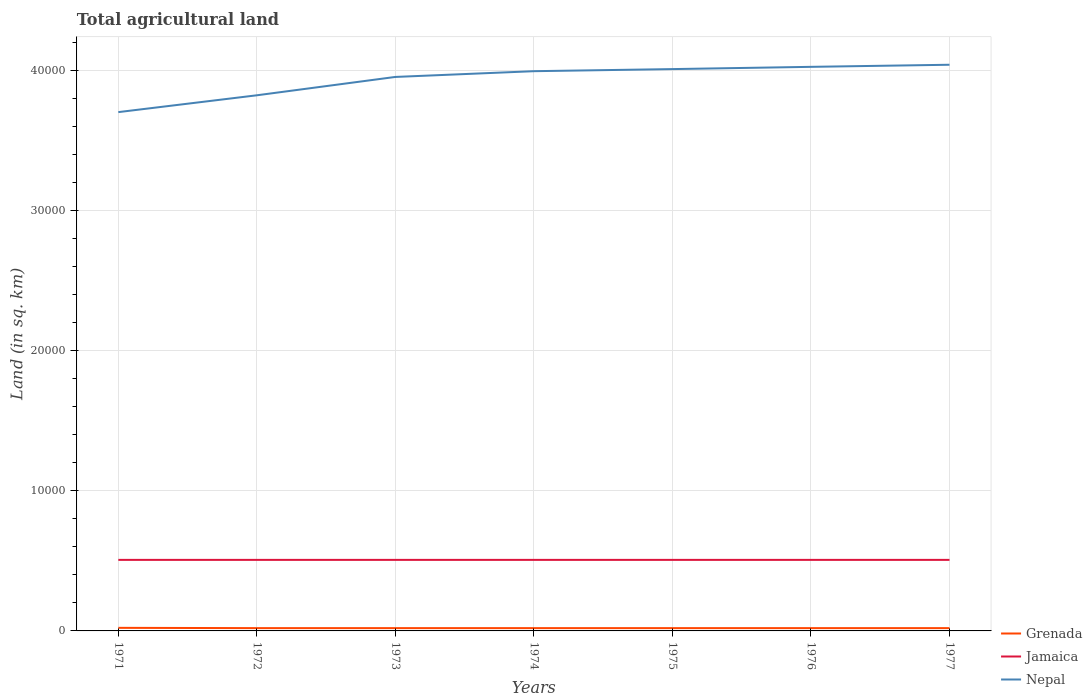Does the line corresponding to Nepal intersect with the line corresponding to Jamaica?
Offer a terse response. No. Across all years, what is the maximum total agricultural land in Grenada?
Your answer should be very brief. 200. What is the total total agricultural land in Grenada in the graph?
Ensure brevity in your answer.  20. What is the difference between the highest and the second highest total agricultural land in Nepal?
Ensure brevity in your answer.  3380. Is the total agricultural land in Grenada strictly greater than the total agricultural land in Jamaica over the years?
Ensure brevity in your answer.  Yes. How many lines are there?
Give a very brief answer. 3. How many years are there in the graph?
Offer a very short reply. 7. Are the values on the major ticks of Y-axis written in scientific E-notation?
Your answer should be very brief. No. Does the graph contain any zero values?
Provide a short and direct response. No. How many legend labels are there?
Provide a short and direct response. 3. How are the legend labels stacked?
Your response must be concise. Vertical. What is the title of the graph?
Keep it short and to the point. Total agricultural land. Does "Panama" appear as one of the legend labels in the graph?
Offer a terse response. No. What is the label or title of the X-axis?
Your answer should be compact. Years. What is the label or title of the Y-axis?
Give a very brief answer. Land (in sq. km). What is the Land (in sq. km) of Grenada in 1971?
Offer a very short reply. 220. What is the Land (in sq. km) of Jamaica in 1971?
Ensure brevity in your answer.  5070. What is the Land (in sq. km) in Nepal in 1971?
Provide a short and direct response. 3.70e+04. What is the Land (in sq. km) in Grenada in 1972?
Give a very brief answer. 200. What is the Land (in sq. km) of Jamaica in 1972?
Give a very brief answer. 5070. What is the Land (in sq. km) of Nepal in 1972?
Give a very brief answer. 3.82e+04. What is the Land (in sq. km) in Jamaica in 1973?
Provide a short and direct response. 5070. What is the Land (in sq. km) in Nepal in 1973?
Offer a very short reply. 3.95e+04. What is the Land (in sq. km) in Jamaica in 1974?
Provide a succinct answer. 5070. What is the Land (in sq. km) of Nepal in 1974?
Your answer should be compact. 3.99e+04. What is the Land (in sq. km) in Grenada in 1975?
Provide a short and direct response. 200. What is the Land (in sq. km) in Jamaica in 1975?
Give a very brief answer. 5070. What is the Land (in sq. km) of Nepal in 1975?
Provide a short and direct response. 4.01e+04. What is the Land (in sq. km) in Grenada in 1976?
Keep it short and to the point. 200. What is the Land (in sq. km) of Jamaica in 1976?
Offer a terse response. 5070. What is the Land (in sq. km) of Nepal in 1976?
Your answer should be compact. 4.02e+04. What is the Land (in sq. km) of Grenada in 1977?
Your answer should be compact. 200. What is the Land (in sq. km) of Jamaica in 1977?
Ensure brevity in your answer.  5070. What is the Land (in sq. km) in Nepal in 1977?
Offer a terse response. 4.04e+04. Across all years, what is the maximum Land (in sq. km) in Grenada?
Your response must be concise. 220. Across all years, what is the maximum Land (in sq. km) of Jamaica?
Provide a succinct answer. 5070. Across all years, what is the maximum Land (in sq. km) of Nepal?
Make the answer very short. 4.04e+04. Across all years, what is the minimum Land (in sq. km) in Grenada?
Ensure brevity in your answer.  200. Across all years, what is the minimum Land (in sq. km) of Jamaica?
Give a very brief answer. 5070. Across all years, what is the minimum Land (in sq. km) in Nepal?
Ensure brevity in your answer.  3.70e+04. What is the total Land (in sq. km) in Grenada in the graph?
Your response must be concise. 1420. What is the total Land (in sq. km) in Jamaica in the graph?
Provide a succinct answer. 3.55e+04. What is the total Land (in sq. km) of Nepal in the graph?
Provide a short and direct response. 2.75e+05. What is the difference between the Land (in sq. km) of Grenada in 1971 and that in 1972?
Ensure brevity in your answer.  20. What is the difference between the Land (in sq. km) of Jamaica in 1971 and that in 1972?
Your answer should be very brief. 0. What is the difference between the Land (in sq. km) in Nepal in 1971 and that in 1972?
Provide a short and direct response. -1200. What is the difference between the Land (in sq. km) of Grenada in 1971 and that in 1973?
Offer a terse response. 20. What is the difference between the Land (in sq. km) of Jamaica in 1971 and that in 1973?
Your response must be concise. 0. What is the difference between the Land (in sq. km) of Nepal in 1971 and that in 1973?
Keep it short and to the point. -2510. What is the difference between the Land (in sq. km) in Nepal in 1971 and that in 1974?
Keep it short and to the point. -2920. What is the difference between the Land (in sq. km) in Jamaica in 1971 and that in 1975?
Your response must be concise. 0. What is the difference between the Land (in sq. km) in Nepal in 1971 and that in 1975?
Your answer should be compact. -3070. What is the difference between the Land (in sq. km) of Grenada in 1971 and that in 1976?
Your response must be concise. 20. What is the difference between the Land (in sq. km) in Jamaica in 1971 and that in 1976?
Ensure brevity in your answer.  0. What is the difference between the Land (in sq. km) of Nepal in 1971 and that in 1976?
Provide a short and direct response. -3230. What is the difference between the Land (in sq. km) of Nepal in 1971 and that in 1977?
Provide a short and direct response. -3380. What is the difference between the Land (in sq. km) of Grenada in 1972 and that in 1973?
Your answer should be very brief. 0. What is the difference between the Land (in sq. km) of Nepal in 1972 and that in 1973?
Your response must be concise. -1310. What is the difference between the Land (in sq. km) in Grenada in 1972 and that in 1974?
Provide a short and direct response. 0. What is the difference between the Land (in sq. km) of Jamaica in 1972 and that in 1974?
Offer a very short reply. 0. What is the difference between the Land (in sq. km) of Nepal in 1972 and that in 1974?
Ensure brevity in your answer.  -1720. What is the difference between the Land (in sq. km) of Nepal in 1972 and that in 1975?
Provide a short and direct response. -1870. What is the difference between the Land (in sq. km) in Grenada in 1972 and that in 1976?
Offer a very short reply. 0. What is the difference between the Land (in sq. km) in Jamaica in 1972 and that in 1976?
Your response must be concise. 0. What is the difference between the Land (in sq. km) in Nepal in 1972 and that in 1976?
Your answer should be very brief. -2030. What is the difference between the Land (in sq. km) of Jamaica in 1972 and that in 1977?
Ensure brevity in your answer.  0. What is the difference between the Land (in sq. km) in Nepal in 1972 and that in 1977?
Offer a very short reply. -2180. What is the difference between the Land (in sq. km) of Grenada in 1973 and that in 1974?
Ensure brevity in your answer.  0. What is the difference between the Land (in sq. km) of Jamaica in 1973 and that in 1974?
Make the answer very short. 0. What is the difference between the Land (in sq. km) in Nepal in 1973 and that in 1974?
Ensure brevity in your answer.  -410. What is the difference between the Land (in sq. km) in Nepal in 1973 and that in 1975?
Ensure brevity in your answer.  -560. What is the difference between the Land (in sq. km) of Grenada in 1973 and that in 1976?
Your answer should be very brief. 0. What is the difference between the Land (in sq. km) in Jamaica in 1973 and that in 1976?
Make the answer very short. 0. What is the difference between the Land (in sq. km) of Nepal in 1973 and that in 1976?
Your answer should be compact. -720. What is the difference between the Land (in sq. km) of Grenada in 1973 and that in 1977?
Provide a short and direct response. 0. What is the difference between the Land (in sq. km) in Jamaica in 1973 and that in 1977?
Your answer should be very brief. 0. What is the difference between the Land (in sq. km) of Nepal in 1973 and that in 1977?
Offer a terse response. -870. What is the difference between the Land (in sq. km) in Grenada in 1974 and that in 1975?
Provide a short and direct response. 0. What is the difference between the Land (in sq. km) of Jamaica in 1974 and that in 1975?
Keep it short and to the point. 0. What is the difference between the Land (in sq. km) of Nepal in 1974 and that in 1975?
Provide a short and direct response. -150. What is the difference between the Land (in sq. km) of Nepal in 1974 and that in 1976?
Give a very brief answer. -310. What is the difference between the Land (in sq. km) in Nepal in 1974 and that in 1977?
Provide a short and direct response. -460. What is the difference between the Land (in sq. km) in Grenada in 1975 and that in 1976?
Ensure brevity in your answer.  0. What is the difference between the Land (in sq. km) of Nepal in 1975 and that in 1976?
Ensure brevity in your answer.  -160. What is the difference between the Land (in sq. km) in Jamaica in 1975 and that in 1977?
Give a very brief answer. 0. What is the difference between the Land (in sq. km) in Nepal in 1975 and that in 1977?
Offer a very short reply. -310. What is the difference between the Land (in sq. km) of Jamaica in 1976 and that in 1977?
Your response must be concise. 0. What is the difference between the Land (in sq. km) in Nepal in 1976 and that in 1977?
Offer a terse response. -150. What is the difference between the Land (in sq. km) in Grenada in 1971 and the Land (in sq. km) in Jamaica in 1972?
Give a very brief answer. -4850. What is the difference between the Land (in sq. km) of Grenada in 1971 and the Land (in sq. km) of Nepal in 1972?
Make the answer very short. -3.80e+04. What is the difference between the Land (in sq. km) of Jamaica in 1971 and the Land (in sq. km) of Nepal in 1972?
Provide a short and direct response. -3.32e+04. What is the difference between the Land (in sq. km) of Grenada in 1971 and the Land (in sq. km) of Jamaica in 1973?
Provide a succinct answer. -4850. What is the difference between the Land (in sq. km) of Grenada in 1971 and the Land (in sq. km) of Nepal in 1973?
Offer a very short reply. -3.93e+04. What is the difference between the Land (in sq. km) of Jamaica in 1971 and the Land (in sq. km) of Nepal in 1973?
Your answer should be very brief. -3.45e+04. What is the difference between the Land (in sq. km) in Grenada in 1971 and the Land (in sq. km) in Jamaica in 1974?
Provide a short and direct response. -4850. What is the difference between the Land (in sq. km) in Grenada in 1971 and the Land (in sq. km) in Nepal in 1974?
Keep it short and to the point. -3.97e+04. What is the difference between the Land (in sq. km) in Jamaica in 1971 and the Land (in sq. km) in Nepal in 1974?
Your answer should be compact. -3.49e+04. What is the difference between the Land (in sq. km) of Grenada in 1971 and the Land (in sq. km) of Jamaica in 1975?
Offer a very short reply. -4850. What is the difference between the Land (in sq. km) of Grenada in 1971 and the Land (in sq. km) of Nepal in 1975?
Offer a very short reply. -3.99e+04. What is the difference between the Land (in sq. km) of Jamaica in 1971 and the Land (in sq. km) of Nepal in 1975?
Provide a succinct answer. -3.50e+04. What is the difference between the Land (in sq. km) in Grenada in 1971 and the Land (in sq. km) in Jamaica in 1976?
Your response must be concise. -4850. What is the difference between the Land (in sq. km) of Grenada in 1971 and the Land (in sq. km) of Nepal in 1976?
Keep it short and to the point. -4.00e+04. What is the difference between the Land (in sq. km) in Jamaica in 1971 and the Land (in sq. km) in Nepal in 1976?
Offer a very short reply. -3.52e+04. What is the difference between the Land (in sq. km) in Grenada in 1971 and the Land (in sq. km) in Jamaica in 1977?
Ensure brevity in your answer.  -4850. What is the difference between the Land (in sq. km) in Grenada in 1971 and the Land (in sq. km) in Nepal in 1977?
Ensure brevity in your answer.  -4.02e+04. What is the difference between the Land (in sq. km) in Jamaica in 1971 and the Land (in sq. km) in Nepal in 1977?
Your answer should be compact. -3.53e+04. What is the difference between the Land (in sq. km) of Grenada in 1972 and the Land (in sq. km) of Jamaica in 1973?
Provide a succinct answer. -4870. What is the difference between the Land (in sq. km) in Grenada in 1972 and the Land (in sq. km) in Nepal in 1973?
Make the answer very short. -3.93e+04. What is the difference between the Land (in sq. km) of Jamaica in 1972 and the Land (in sq. km) of Nepal in 1973?
Your answer should be compact. -3.45e+04. What is the difference between the Land (in sq. km) in Grenada in 1972 and the Land (in sq. km) in Jamaica in 1974?
Ensure brevity in your answer.  -4870. What is the difference between the Land (in sq. km) in Grenada in 1972 and the Land (in sq. km) in Nepal in 1974?
Give a very brief answer. -3.97e+04. What is the difference between the Land (in sq. km) in Jamaica in 1972 and the Land (in sq. km) in Nepal in 1974?
Offer a very short reply. -3.49e+04. What is the difference between the Land (in sq. km) in Grenada in 1972 and the Land (in sq. km) in Jamaica in 1975?
Make the answer very short. -4870. What is the difference between the Land (in sq. km) in Grenada in 1972 and the Land (in sq. km) in Nepal in 1975?
Give a very brief answer. -3.99e+04. What is the difference between the Land (in sq. km) of Jamaica in 1972 and the Land (in sq. km) of Nepal in 1975?
Your answer should be very brief. -3.50e+04. What is the difference between the Land (in sq. km) of Grenada in 1972 and the Land (in sq. km) of Jamaica in 1976?
Your answer should be very brief. -4870. What is the difference between the Land (in sq. km) of Grenada in 1972 and the Land (in sq. km) of Nepal in 1976?
Provide a short and direct response. -4.00e+04. What is the difference between the Land (in sq. km) of Jamaica in 1972 and the Land (in sq. km) of Nepal in 1976?
Your answer should be compact. -3.52e+04. What is the difference between the Land (in sq. km) of Grenada in 1972 and the Land (in sq. km) of Jamaica in 1977?
Your answer should be compact. -4870. What is the difference between the Land (in sq. km) of Grenada in 1972 and the Land (in sq. km) of Nepal in 1977?
Provide a short and direct response. -4.02e+04. What is the difference between the Land (in sq. km) of Jamaica in 1972 and the Land (in sq. km) of Nepal in 1977?
Ensure brevity in your answer.  -3.53e+04. What is the difference between the Land (in sq. km) of Grenada in 1973 and the Land (in sq. km) of Jamaica in 1974?
Ensure brevity in your answer.  -4870. What is the difference between the Land (in sq. km) of Grenada in 1973 and the Land (in sq. km) of Nepal in 1974?
Provide a succinct answer. -3.97e+04. What is the difference between the Land (in sq. km) of Jamaica in 1973 and the Land (in sq. km) of Nepal in 1974?
Provide a short and direct response. -3.49e+04. What is the difference between the Land (in sq. km) in Grenada in 1973 and the Land (in sq. km) in Jamaica in 1975?
Offer a very short reply. -4870. What is the difference between the Land (in sq. km) of Grenada in 1973 and the Land (in sq. km) of Nepal in 1975?
Ensure brevity in your answer.  -3.99e+04. What is the difference between the Land (in sq. km) in Jamaica in 1973 and the Land (in sq. km) in Nepal in 1975?
Offer a terse response. -3.50e+04. What is the difference between the Land (in sq. km) of Grenada in 1973 and the Land (in sq. km) of Jamaica in 1976?
Ensure brevity in your answer.  -4870. What is the difference between the Land (in sq. km) in Grenada in 1973 and the Land (in sq. km) in Nepal in 1976?
Your response must be concise. -4.00e+04. What is the difference between the Land (in sq. km) of Jamaica in 1973 and the Land (in sq. km) of Nepal in 1976?
Make the answer very short. -3.52e+04. What is the difference between the Land (in sq. km) in Grenada in 1973 and the Land (in sq. km) in Jamaica in 1977?
Make the answer very short. -4870. What is the difference between the Land (in sq. km) of Grenada in 1973 and the Land (in sq. km) of Nepal in 1977?
Offer a terse response. -4.02e+04. What is the difference between the Land (in sq. km) of Jamaica in 1973 and the Land (in sq. km) of Nepal in 1977?
Provide a succinct answer. -3.53e+04. What is the difference between the Land (in sq. km) of Grenada in 1974 and the Land (in sq. km) of Jamaica in 1975?
Ensure brevity in your answer.  -4870. What is the difference between the Land (in sq. km) of Grenada in 1974 and the Land (in sq. km) of Nepal in 1975?
Your answer should be very brief. -3.99e+04. What is the difference between the Land (in sq. km) in Jamaica in 1974 and the Land (in sq. km) in Nepal in 1975?
Your answer should be very brief. -3.50e+04. What is the difference between the Land (in sq. km) of Grenada in 1974 and the Land (in sq. km) of Jamaica in 1976?
Your response must be concise. -4870. What is the difference between the Land (in sq. km) in Grenada in 1974 and the Land (in sq. km) in Nepal in 1976?
Provide a short and direct response. -4.00e+04. What is the difference between the Land (in sq. km) in Jamaica in 1974 and the Land (in sq. km) in Nepal in 1976?
Keep it short and to the point. -3.52e+04. What is the difference between the Land (in sq. km) in Grenada in 1974 and the Land (in sq. km) in Jamaica in 1977?
Your answer should be very brief. -4870. What is the difference between the Land (in sq. km) in Grenada in 1974 and the Land (in sq. km) in Nepal in 1977?
Make the answer very short. -4.02e+04. What is the difference between the Land (in sq. km) of Jamaica in 1974 and the Land (in sq. km) of Nepal in 1977?
Provide a short and direct response. -3.53e+04. What is the difference between the Land (in sq. km) of Grenada in 1975 and the Land (in sq. km) of Jamaica in 1976?
Your answer should be compact. -4870. What is the difference between the Land (in sq. km) of Grenada in 1975 and the Land (in sq. km) of Nepal in 1976?
Ensure brevity in your answer.  -4.00e+04. What is the difference between the Land (in sq. km) of Jamaica in 1975 and the Land (in sq. km) of Nepal in 1976?
Give a very brief answer. -3.52e+04. What is the difference between the Land (in sq. km) of Grenada in 1975 and the Land (in sq. km) of Jamaica in 1977?
Offer a terse response. -4870. What is the difference between the Land (in sq. km) in Grenada in 1975 and the Land (in sq. km) in Nepal in 1977?
Your answer should be compact. -4.02e+04. What is the difference between the Land (in sq. km) in Jamaica in 1975 and the Land (in sq. km) in Nepal in 1977?
Offer a very short reply. -3.53e+04. What is the difference between the Land (in sq. km) of Grenada in 1976 and the Land (in sq. km) of Jamaica in 1977?
Provide a short and direct response. -4870. What is the difference between the Land (in sq. km) in Grenada in 1976 and the Land (in sq. km) in Nepal in 1977?
Offer a very short reply. -4.02e+04. What is the difference between the Land (in sq. km) in Jamaica in 1976 and the Land (in sq. km) in Nepal in 1977?
Provide a succinct answer. -3.53e+04. What is the average Land (in sq. km) in Grenada per year?
Make the answer very short. 202.86. What is the average Land (in sq. km) of Jamaica per year?
Provide a succinct answer. 5070. What is the average Land (in sq. km) of Nepal per year?
Give a very brief answer. 3.94e+04. In the year 1971, what is the difference between the Land (in sq. km) in Grenada and Land (in sq. km) in Jamaica?
Offer a terse response. -4850. In the year 1971, what is the difference between the Land (in sq. km) of Grenada and Land (in sq. km) of Nepal?
Offer a terse response. -3.68e+04. In the year 1971, what is the difference between the Land (in sq. km) in Jamaica and Land (in sq. km) in Nepal?
Ensure brevity in your answer.  -3.20e+04. In the year 1972, what is the difference between the Land (in sq. km) of Grenada and Land (in sq. km) of Jamaica?
Offer a terse response. -4870. In the year 1972, what is the difference between the Land (in sq. km) of Grenada and Land (in sq. km) of Nepal?
Keep it short and to the point. -3.80e+04. In the year 1972, what is the difference between the Land (in sq. km) of Jamaica and Land (in sq. km) of Nepal?
Ensure brevity in your answer.  -3.32e+04. In the year 1973, what is the difference between the Land (in sq. km) of Grenada and Land (in sq. km) of Jamaica?
Offer a very short reply. -4870. In the year 1973, what is the difference between the Land (in sq. km) of Grenada and Land (in sq. km) of Nepal?
Your answer should be very brief. -3.93e+04. In the year 1973, what is the difference between the Land (in sq. km) of Jamaica and Land (in sq. km) of Nepal?
Give a very brief answer. -3.45e+04. In the year 1974, what is the difference between the Land (in sq. km) of Grenada and Land (in sq. km) of Jamaica?
Keep it short and to the point. -4870. In the year 1974, what is the difference between the Land (in sq. km) of Grenada and Land (in sq. km) of Nepal?
Provide a short and direct response. -3.97e+04. In the year 1974, what is the difference between the Land (in sq. km) of Jamaica and Land (in sq. km) of Nepal?
Provide a short and direct response. -3.49e+04. In the year 1975, what is the difference between the Land (in sq. km) in Grenada and Land (in sq. km) in Jamaica?
Provide a succinct answer. -4870. In the year 1975, what is the difference between the Land (in sq. km) in Grenada and Land (in sq. km) in Nepal?
Make the answer very short. -3.99e+04. In the year 1975, what is the difference between the Land (in sq. km) of Jamaica and Land (in sq. km) of Nepal?
Your response must be concise. -3.50e+04. In the year 1976, what is the difference between the Land (in sq. km) of Grenada and Land (in sq. km) of Jamaica?
Give a very brief answer. -4870. In the year 1976, what is the difference between the Land (in sq. km) in Grenada and Land (in sq. km) in Nepal?
Your response must be concise. -4.00e+04. In the year 1976, what is the difference between the Land (in sq. km) of Jamaica and Land (in sq. km) of Nepal?
Give a very brief answer. -3.52e+04. In the year 1977, what is the difference between the Land (in sq. km) of Grenada and Land (in sq. km) of Jamaica?
Give a very brief answer. -4870. In the year 1977, what is the difference between the Land (in sq. km) of Grenada and Land (in sq. km) of Nepal?
Provide a succinct answer. -4.02e+04. In the year 1977, what is the difference between the Land (in sq. km) in Jamaica and Land (in sq. km) in Nepal?
Keep it short and to the point. -3.53e+04. What is the ratio of the Land (in sq. km) in Grenada in 1971 to that in 1972?
Make the answer very short. 1.1. What is the ratio of the Land (in sq. km) of Jamaica in 1971 to that in 1972?
Keep it short and to the point. 1. What is the ratio of the Land (in sq. km) of Nepal in 1971 to that in 1972?
Provide a short and direct response. 0.97. What is the ratio of the Land (in sq. km) of Grenada in 1971 to that in 1973?
Make the answer very short. 1.1. What is the ratio of the Land (in sq. km) of Jamaica in 1971 to that in 1973?
Offer a very short reply. 1. What is the ratio of the Land (in sq. km) in Nepal in 1971 to that in 1973?
Your response must be concise. 0.94. What is the ratio of the Land (in sq. km) in Nepal in 1971 to that in 1974?
Make the answer very short. 0.93. What is the ratio of the Land (in sq. km) of Nepal in 1971 to that in 1975?
Provide a short and direct response. 0.92. What is the ratio of the Land (in sq. km) of Nepal in 1971 to that in 1976?
Offer a terse response. 0.92. What is the ratio of the Land (in sq. km) of Grenada in 1971 to that in 1977?
Offer a terse response. 1.1. What is the ratio of the Land (in sq. km) in Jamaica in 1971 to that in 1977?
Provide a succinct answer. 1. What is the ratio of the Land (in sq. km) of Nepal in 1971 to that in 1977?
Offer a terse response. 0.92. What is the ratio of the Land (in sq. km) in Nepal in 1972 to that in 1973?
Ensure brevity in your answer.  0.97. What is the ratio of the Land (in sq. km) in Grenada in 1972 to that in 1974?
Offer a terse response. 1. What is the ratio of the Land (in sq. km) of Nepal in 1972 to that in 1974?
Your response must be concise. 0.96. What is the ratio of the Land (in sq. km) in Jamaica in 1972 to that in 1975?
Offer a terse response. 1. What is the ratio of the Land (in sq. km) of Nepal in 1972 to that in 1975?
Ensure brevity in your answer.  0.95. What is the ratio of the Land (in sq. km) of Jamaica in 1972 to that in 1976?
Make the answer very short. 1. What is the ratio of the Land (in sq. km) in Nepal in 1972 to that in 1976?
Provide a succinct answer. 0.95. What is the ratio of the Land (in sq. km) of Nepal in 1972 to that in 1977?
Ensure brevity in your answer.  0.95. What is the ratio of the Land (in sq. km) of Jamaica in 1973 to that in 1974?
Offer a very short reply. 1. What is the ratio of the Land (in sq. km) of Nepal in 1973 to that in 1974?
Keep it short and to the point. 0.99. What is the ratio of the Land (in sq. km) of Grenada in 1973 to that in 1975?
Your response must be concise. 1. What is the ratio of the Land (in sq. km) of Nepal in 1973 to that in 1975?
Provide a short and direct response. 0.99. What is the ratio of the Land (in sq. km) in Nepal in 1973 to that in 1976?
Your answer should be compact. 0.98. What is the ratio of the Land (in sq. km) in Jamaica in 1973 to that in 1977?
Ensure brevity in your answer.  1. What is the ratio of the Land (in sq. km) of Nepal in 1973 to that in 1977?
Give a very brief answer. 0.98. What is the ratio of the Land (in sq. km) in Jamaica in 1974 to that in 1975?
Keep it short and to the point. 1. What is the ratio of the Land (in sq. km) of Grenada in 1974 to that in 1976?
Ensure brevity in your answer.  1. What is the ratio of the Land (in sq. km) of Jamaica in 1974 to that in 1976?
Provide a succinct answer. 1. What is the ratio of the Land (in sq. km) of Nepal in 1975 to that in 1976?
Your response must be concise. 1. What is the ratio of the Land (in sq. km) in Grenada in 1975 to that in 1977?
Ensure brevity in your answer.  1. What is the ratio of the Land (in sq. km) in Grenada in 1976 to that in 1977?
Ensure brevity in your answer.  1. What is the difference between the highest and the second highest Land (in sq. km) in Jamaica?
Keep it short and to the point. 0. What is the difference between the highest and the second highest Land (in sq. km) of Nepal?
Your response must be concise. 150. What is the difference between the highest and the lowest Land (in sq. km) of Grenada?
Your answer should be very brief. 20. What is the difference between the highest and the lowest Land (in sq. km) in Nepal?
Your answer should be compact. 3380. 